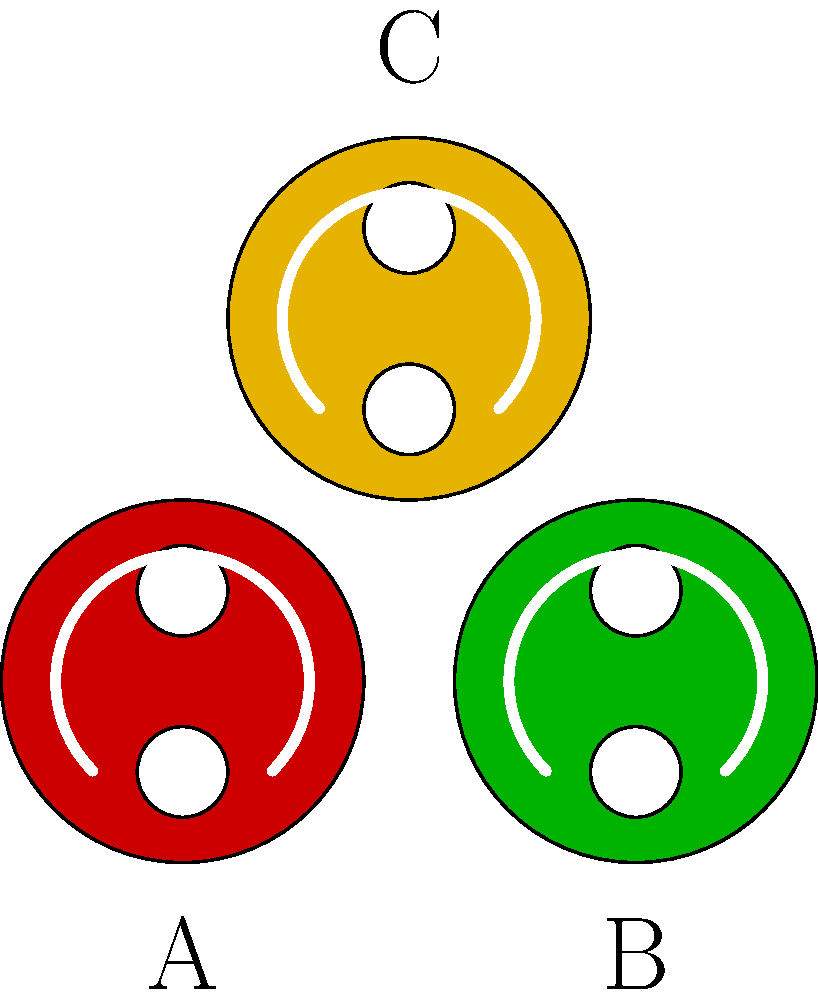As a jazz musician performing during Mardi Gras, you come across three traditional mask designs. Which of these masks (A, B, or C) is most likely to represent the "Zulu" krewe, known for its distinctive use of coconuts as throws? To answer this question, let's consider the characteristics of each mask and their cultural significance in Mardi Gras traditions:

1. Mask A (Red): This mask represents a traditional Mardi Gras color, but it's not specifically associated with the Zulu krewe.

2. Mask B (Green): Green is another traditional Mardi Gras color, often representing faith, but it's not particularly linked to the Zulu krewe.

3. Mask C (Gold/Yellow): This mask is the most likely to represent the Zulu krewe for several reasons:
   a. The Zulu Social Aid and Pleasure Club, founded in 1909, is known for its distinctive gold-painted coconuts as throws.
   b. The color gold or yellow is often associated with the Zulu krewe's costumes and decorations.
   c. The Zulu king typically wears a golden crown and carries a golden scepter.

The Zulu krewe's use of gold/yellow is a nod to African royalty and their rich cultural heritage. As a jazz musician performing during Mardi Gras, you would likely be familiar with the Zulu parade, as it often features jazz bands and is a significant part of New Orleans' musical tradition during the festivities.

Therefore, based on the cultural significance and color association, Mask C is most likely to represent the Zulu krewe.
Answer: C 